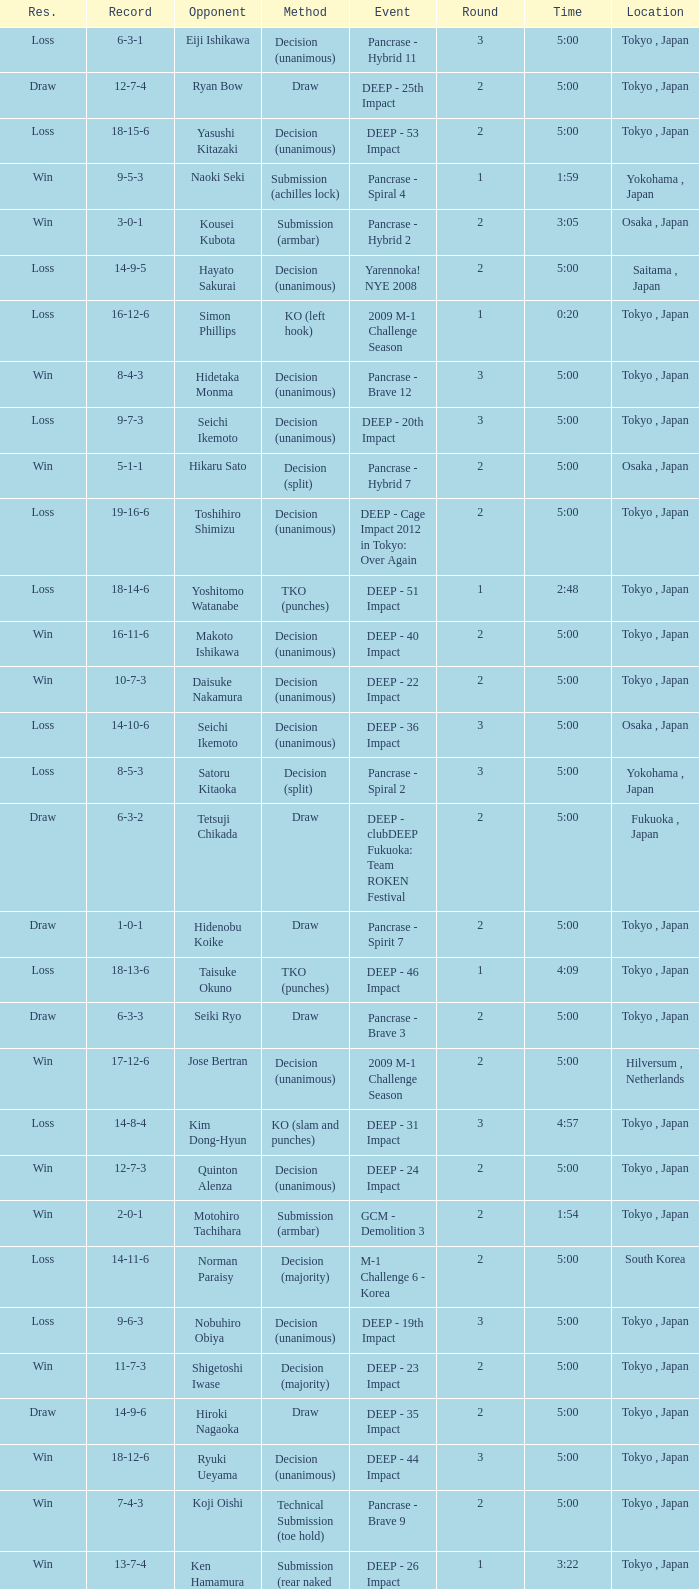What is the location when the method is tko (punches) and the time is 2:48? Tokyo , Japan. 